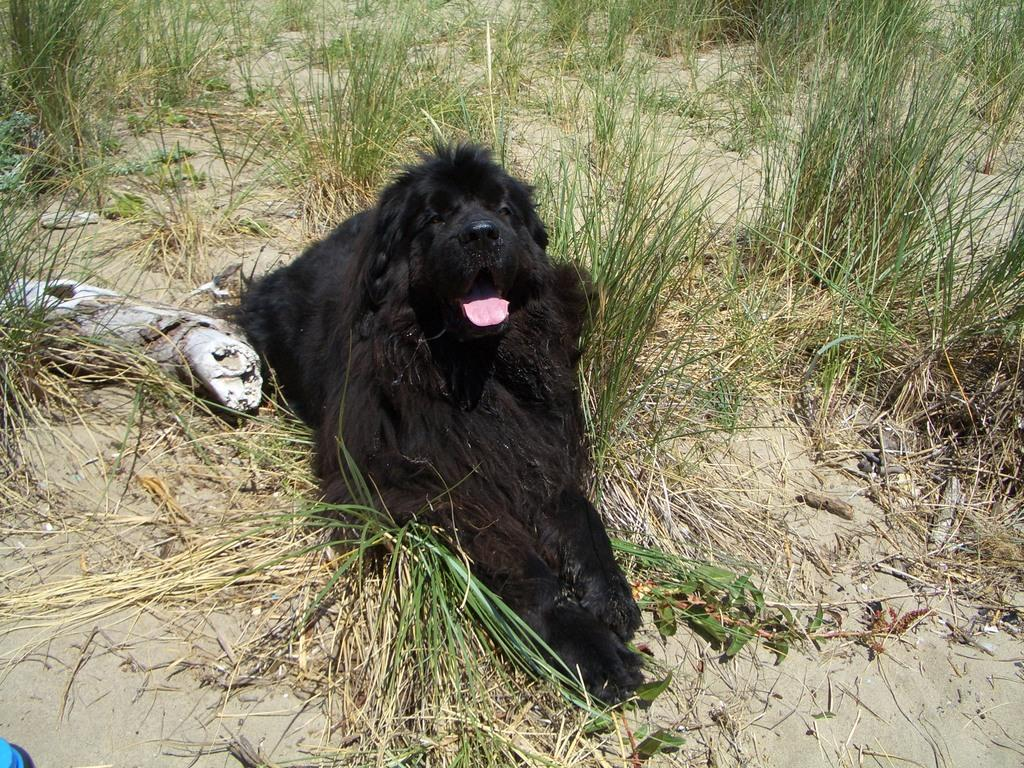What animal can be seen in the image? There is a dog in the image. What position is the dog in? The dog is sitting on the ground. What type of surface is the dog sitting on? There is grass on the ground. What else can be seen on the ground in the image? There are dried stems on the ground. Where is the nearest shop to the dog in the image? There is no shop mentioned or visible in the image. 